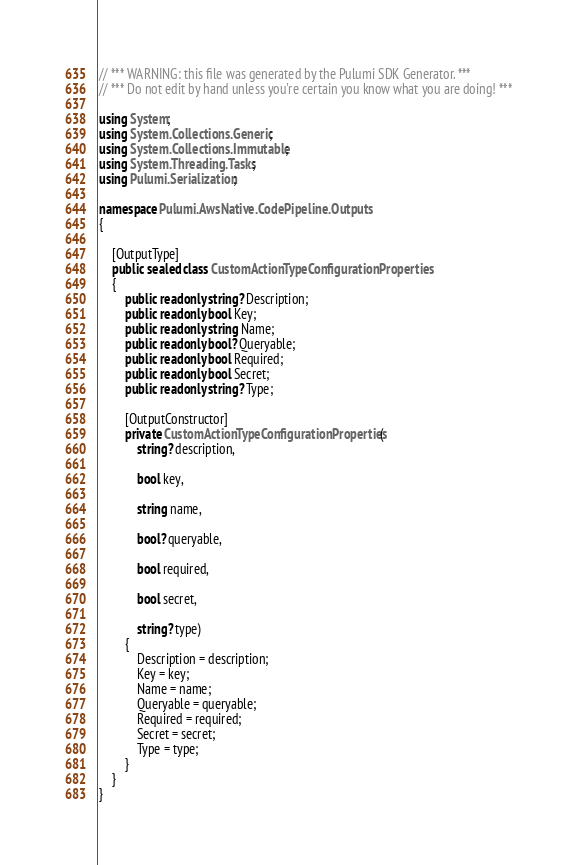<code> <loc_0><loc_0><loc_500><loc_500><_C#_>// *** WARNING: this file was generated by the Pulumi SDK Generator. ***
// *** Do not edit by hand unless you're certain you know what you are doing! ***

using System;
using System.Collections.Generic;
using System.Collections.Immutable;
using System.Threading.Tasks;
using Pulumi.Serialization;

namespace Pulumi.AwsNative.CodePipeline.Outputs
{

    [OutputType]
    public sealed class CustomActionTypeConfigurationProperties
    {
        public readonly string? Description;
        public readonly bool Key;
        public readonly string Name;
        public readonly bool? Queryable;
        public readonly bool Required;
        public readonly bool Secret;
        public readonly string? Type;

        [OutputConstructor]
        private CustomActionTypeConfigurationProperties(
            string? description,

            bool key,

            string name,

            bool? queryable,

            bool required,

            bool secret,

            string? type)
        {
            Description = description;
            Key = key;
            Name = name;
            Queryable = queryable;
            Required = required;
            Secret = secret;
            Type = type;
        }
    }
}
</code> 